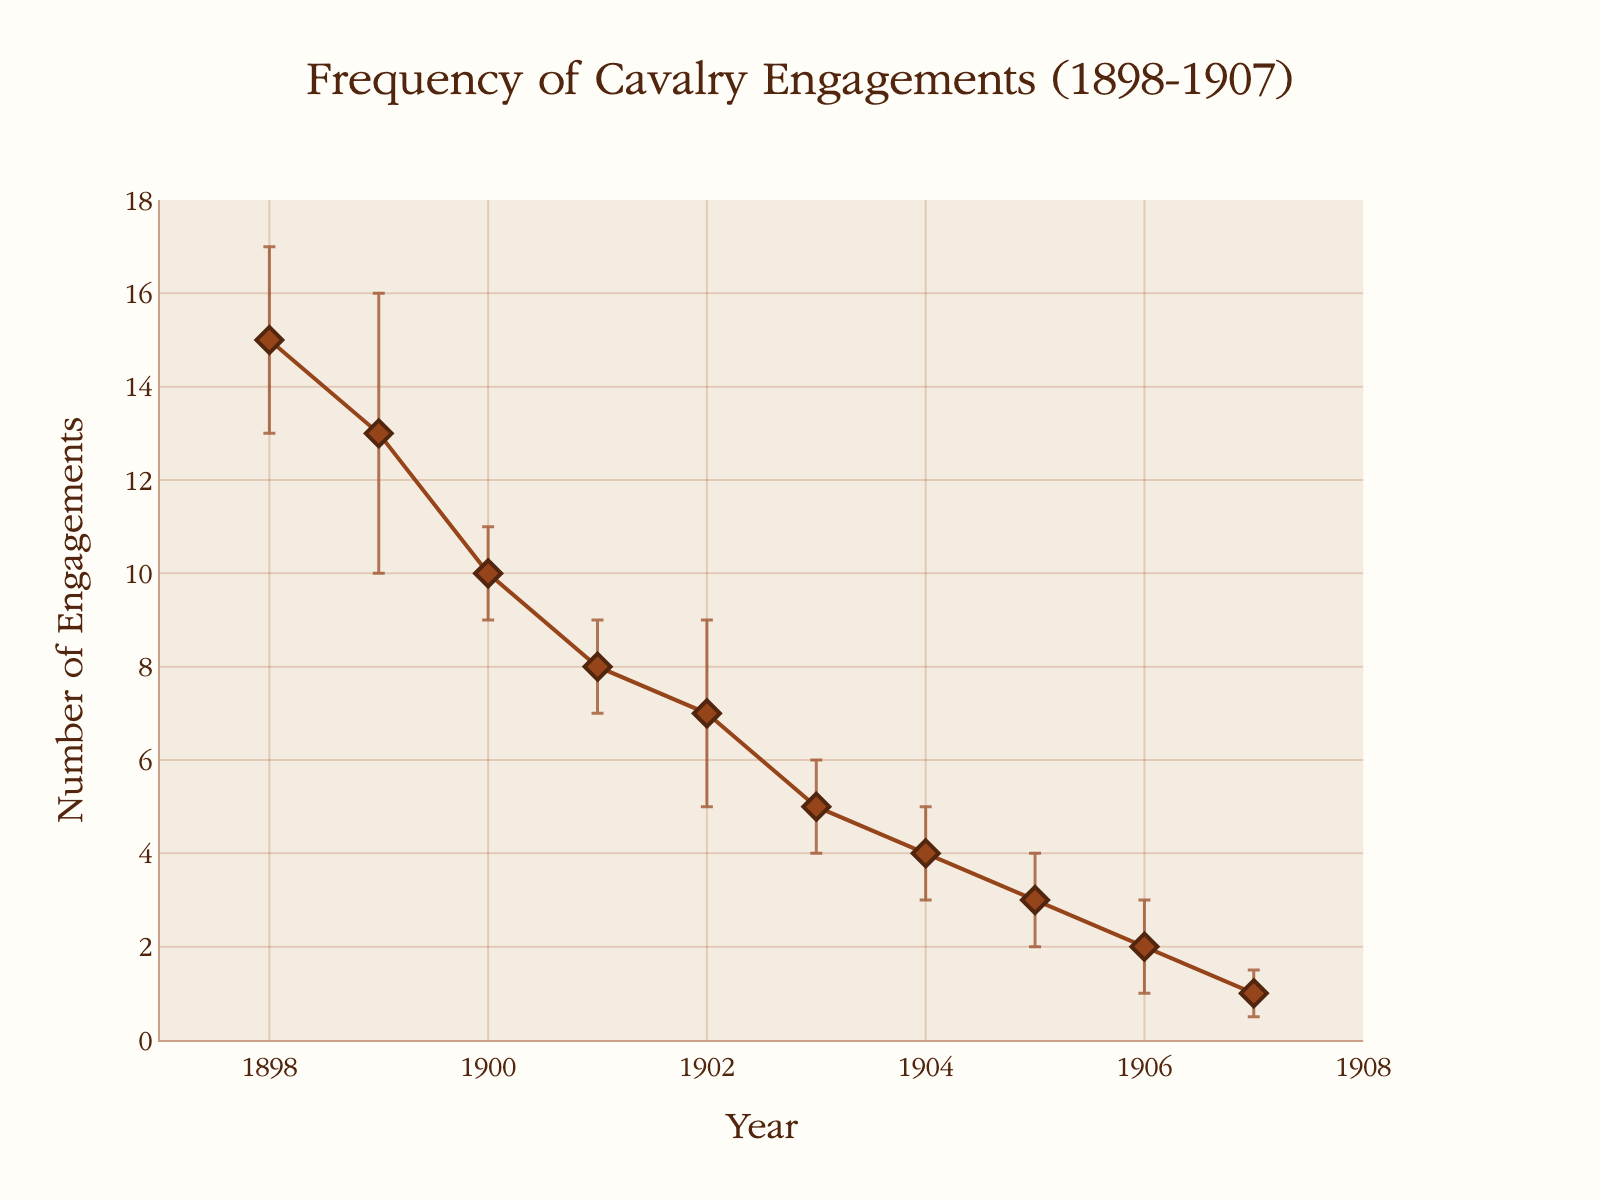What's the title of the plot? The title of the plot is usually displayed prominently at the top of the figure. In this plot, the title is "Frequency of Cavalry Engagements (1898-1907)."
Answer: Frequency of Cavalry Engagements (1898-1907) What are the units of the y-axis? The y-axis represents the number of engagements, as indicated by the y-axis title "Number of Engagements."
Answer: Number of Engagements How many total data points are there? Each data point represents a year from 1898 to 1907. Counting each year, we have 10 data points.
Answer: 10 What's the range of error bars for the year 1899? The range can be found by looking at the error value and adding/subtracting it from the engagement value. For 1899, the engagements are 13 with an error of ±3. So the range is 10 to 16.
Answer: 10 to 16 In which year did the number of cavalry engagements drop to 1? By examining the plot, we see that the number of engagements drops to 1 in the year 1907.
Answer: 1907 Which year had the highest number of cavalry engagements? The year with the highest number of engagements can be seen at the peak of the plot. This is in 1898 with 15 engagements.
Answer: 1898 What is the difference in the number of engagements between 1900 and 1903? The number of engagements in 1900 is 10, and in 1903 it is 5. The difference is 10 - 5 = 5.
Answer: 5 Is there a year where the number of engagements decreased by more than 50% compared to the previous year? We need to check each pair of successive years. From 1900 to 1901, engagements go from 10 to 8 (not over 50%). From 1902 to 1903, engagements go from 7 to 5 (not over 50%). From 1904 to 1905, engagements drop from 4 to 3, which is a drop of 25%. From 1905 to 1906, engagements drop from 3 to 2 (drop of ≈33.3%). Therefore, no year shows more than a 50% decrease.
Answer: No Which year has the smallest error margin? By looking at the error bars, the smallest error margin (0.5) is in the year 1907.
Answer: 1907 What is the average number of engagements over the years? To find the average, sum all the engagements and divide by the number of years. The total is 15 + 13 + 10 + 8 + 7 + 5 + 4 + 3 + 2 + 1 = 68. The average is 68 / 10 = 6.8.
Answer: 6.8 